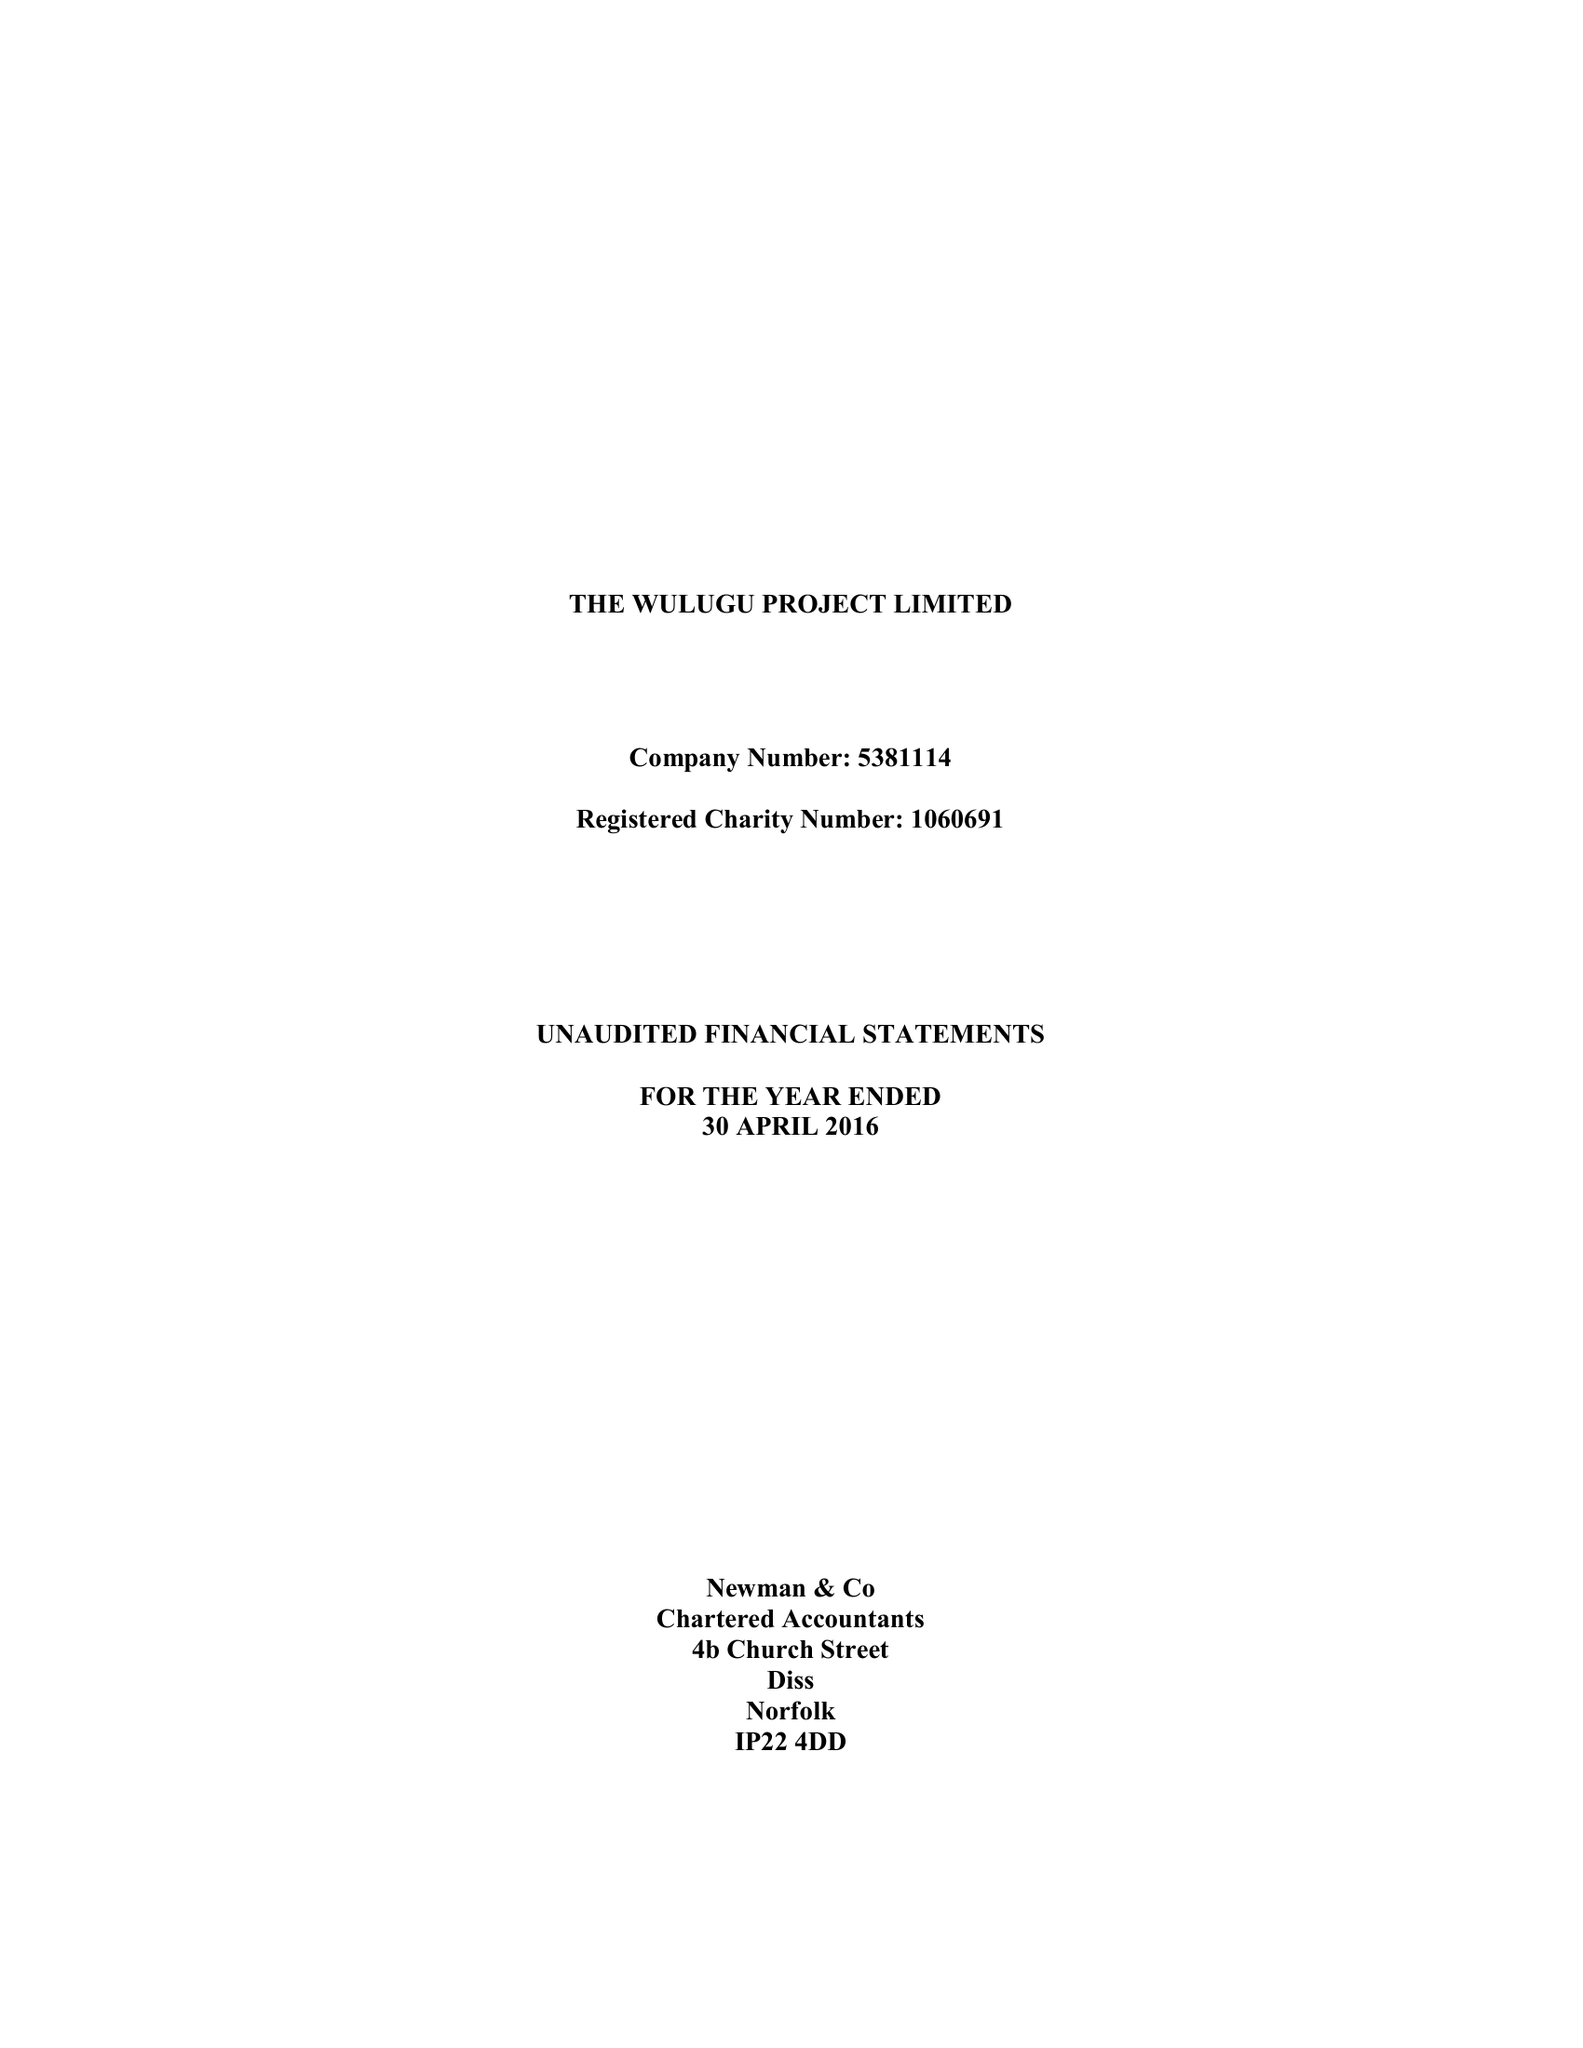What is the value for the report_date?
Answer the question using a single word or phrase. 2016-04-30 